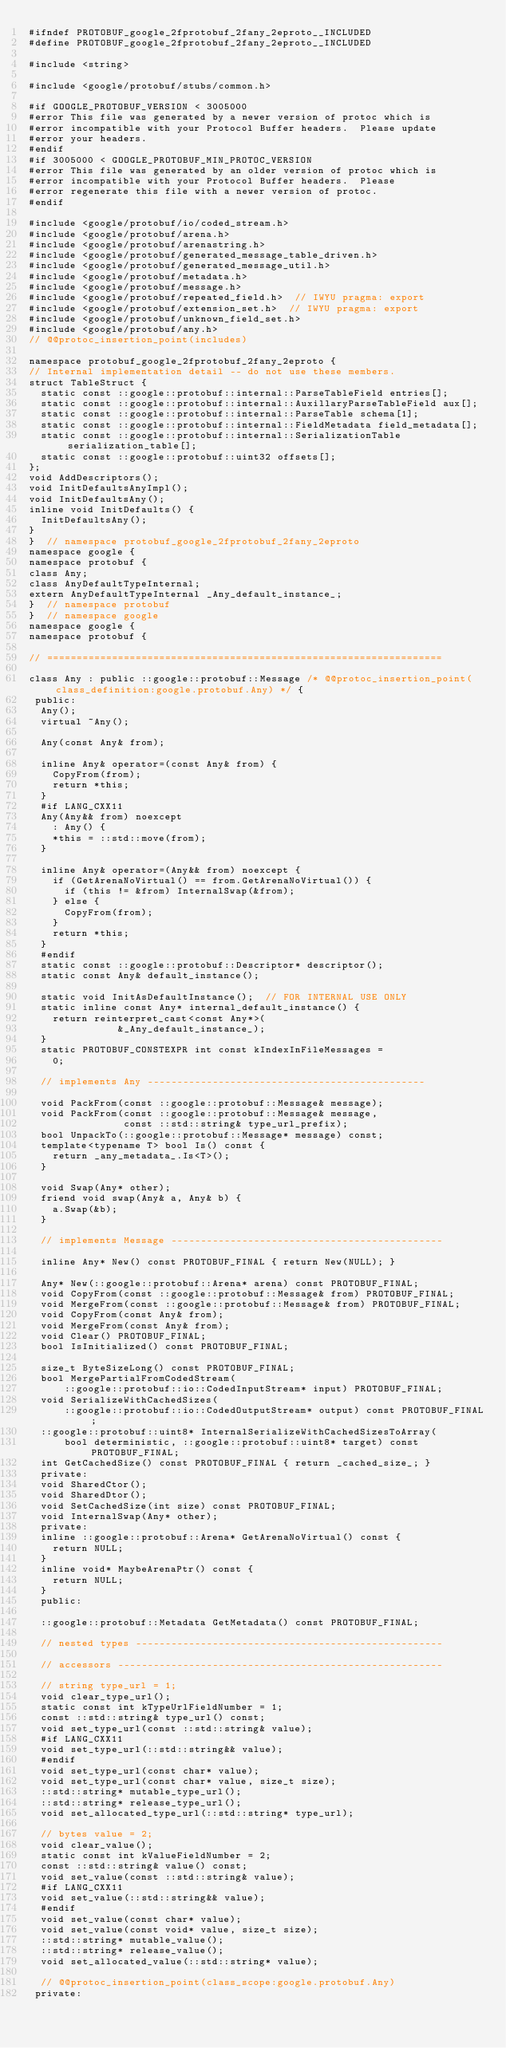Convert code to text. <code><loc_0><loc_0><loc_500><loc_500><_C_>#ifndef PROTOBUF_google_2fprotobuf_2fany_2eproto__INCLUDED
#define PROTOBUF_google_2fprotobuf_2fany_2eproto__INCLUDED

#include <string>

#include <google/protobuf/stubs/common.h>

#if GOOGLE_PROTOBUF_VERSION < 3005000
#error This file was generated by a newer version of protoc which is
#error incompatible with your Protocol Buffer headers.  Please update
#error your headers.
#endif
#if 3005000 < GOOGLE_PROTOBUF_MIN_PROTOC_VERSION
#error This file was generated by an older version of protoc which is
#error incompatible with your Protocol Buffer headers.  Please
#error regenerate this file with a newer version of protoc.
#endif

#include <google/protobuf/io/coded_stream.h>
#include <google/protobuf/arena.h>
#include <google/protobuf/arenastring.h>
#include <google/protobuf/generated_message_table_driven.h>
#include <google/protobuf/generated_message_util.h>
#include <google/protobuf/metadata.h>
#include <google/protobuf/message.h>
#include <google/protobuf/repeated_field.h>  // IWYU pragma: export
#include <google/protobuf/extension_set.h>  // IWYU pragma: export
#include <google/protobuf/unknown_field_set.h>
#include <google/protobuf/any.h>
// @@protoc_insertion_point(includes)

namespace protobuf_google_2fprotobuf_2fany_2eproto {
// Internal implementation detail -- do not use these members.
struct TableStruct {
  static const ::google::protobuf::internal::ParseTableField entries[];
  static const ::google::protobuf::internal::AuxillaryParseTableField aux[];
  static const ::google::protobuf::internal::ParseTable schema[1];
  static const ::google::protobuf::internal::FieldMetadata field_metadata[];
  static const ::google::protobuf::internal::SerializationTable serialization_table[];
  static const ::google::protobuf::uint32 offsets[];
};
void AddDescriptors();
void InitDefaultsAnyImpl();
void InitDefaultsAny();
inline void InitDefaults() {
  InitDefaultsAny();
}
}  // namespace protobuf_google_2fprotobuf_2fany_2eproto
namespace google {
namespace protobuf {
class Any;
class AnyDefaultTypeInternal;
extern AnyDefaultTypeInternal _Any_default_instance_;
}  // namespace protobuf
}  // namespace google
namespace google {
namespace protobuf {

// ===================================================================

class Any : public ::google::protobuf::Message /* @@protoc_insertion_point(class_definition:google.protobuf.Any) */ {
 public:
  Any();
  virtual ~Any();

  Any(const Any& from);

  inline Any& operator=(const Any& from) {
    CopyFrom(from);
    return *this;
  }
  #if LANG_CXX11
  Any(Any&& from) noexcept
    : Any() {
    *this = ::std::move(from);
  }

  inline Any& operator=(Any&& from) noexcept {
    if (GetArenaNoVirtual() == from.GetArenaNoVirtual()) {
      if (this != &from) InternalSwap(&from);
    } else {
      CopyFrom(from);
    }
    return *this;
  }
  #endif
  static const ::google::protobuf::Descriptor* descriptor();
  static const Any& default_instance();

  static void InitAsDefaultInstance();  // FOR INTERNAL USE ONLY
  static inline const Any* internal_default_instance() {
    return reinterpret_cast<const Any*>(
               &_Any_default_instance_);
  }
  static PROTOBUF_CONSTEXPR int const kIndexInFileMessages =
    0;

  // implements Any -----------------------------------------------

  void PackFrom(const ::google::protobuf::Message& message);
  void PackFrom(const ::google::protobuf::Message& message,
                const ::std::string& type_url_prefix);
  bool UnpackTo(::google::protobuf::Message* message) const;
  template<typename T> bool Is() const {
    return _any_metadata_.Is<T>();
  }

  void Swap(Any* other);
  friend void swap(Any& a, Any& b) {
    a.Swap(&b);
  }

  // implements Message ----------------------------------------------

  inline Any* New() const PROTOBUF_FINAL { return New(NULL); }

  Any* New(::google::protobuf::Arena* arena) const PROTOBUF_FINAL;
  void CopyFrom(const ::google::protobuf::Message& from) PROTOBUF_FINAL;
  void MergeFrom(const ::google::protobuf::Message& from) PROTOBUF_FINAL;
  void CopyFrom(const Any& from);
  void MergeFrom(const Any& from);
  void Clear() PROTOBUF_FINAL;
  bool IsInitialized() const PROTOBUF_FINAL;

  size_t ByteSizeLong() const PROTOBUF_FINAL;
  bool MergePartialFromCodedStream(
      ::google::protobuf::io::CodedInputStream* input) PROTOBUF_FINAL;
  void SerializeWithCachedSizes(
      ::google::protobuf::io::CodedOutputStream* output) const PROTOBUF_FINAL;
  ::google::protobuf::uint8* InternalSerializeWithCachedSizesToArray(
      bool deterministic, ::google::protobuf::uint8* target) const PROTOBUF_FINAL;
  int GetCachedSize() const PROTOBUF_FINAL { return _cached_size_; }
  private:
  void SharedCtor();
  void SharedDtor();
  void SetCachedSize(int size) const PROTOBUF_FINAL;
  void InternalSwap(Any* other);
  private:
  inline ::google::protobuf::Arena* GetArenaNoVirtual() const {
    return NULL;
  }
  inline void* MaybeArenaPtr() const {
    return NULL;
  }
  public:

  ::google::protobuf::Metadata GetMetadata() const PROTOBUF_FINAL;

  // nested types ----------------------------------------------------

  // accessors -------------------------------------------------------

  // string type_url = 1;
  void clear_type_url();
  static const int kTypeUrlFieldNumber = 1;
  const ::std::string& type_url() const;
  void set_type_url(const ::std::string& value);
  #if LANG_CXX11
  void set_type_url(::std::string&& value);
  #endif
  void set_type_url(const char* value);
  void set_type_url(const char* value, size_t size);
  ::std::string* mutable_type_url();
  ::std::string* release_type_url();
  void set_allocated_type_url(::std::string* type_url);

  // bytes value = 2;
  void clear_value();
  static const int kValueFieldNumber = 2;
  const ::std::string& value() const;
  void set_value(const ::std::string& value);
  #if LANG_CXX11
  void set_value(::std::string&& value);
  #endif
  void set_value(const char* value);
  void set_value(const void* value, size_t size);
  ::std::string* mutable_value();
  ::std::string* release_value();
  void set_allocated_value(::std::string* value);

  // @@protoc_insertion_point(class_scope:google.protobuf.Any)
 private:
</code> 